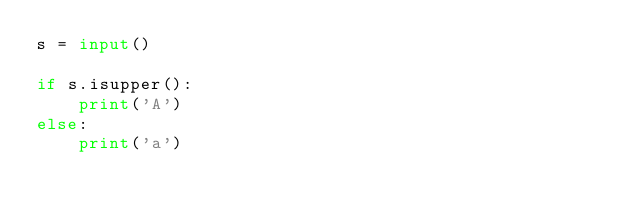<code> <loc_0><loc_0><loc_500><loc_500><_Python_>s = input()

if s.isupper():
    print('A')
else:
    print('a')


</code> 